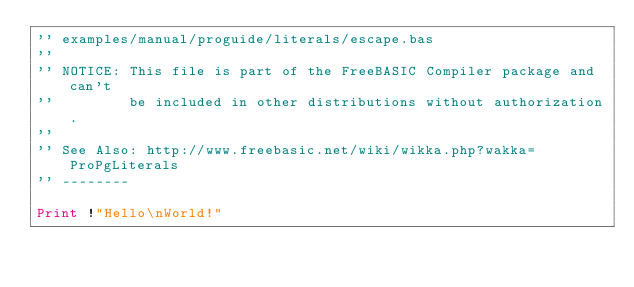<code> <loc_0><loc_0><loc_500><loc_500><_VisualBasic_>'' examples/manual/proguide/literals/escape.bas
''
'' NOTICE: This file is part of the FreeBASIC Compiler package and can't
''         be included in other distributions without authorization.
''
'' See Also: http://www.freebasic.net/wiki/wikka.php?wakka=ProPgLiterals
'' --------

Print !"Hello\nWorld!"
</code> 